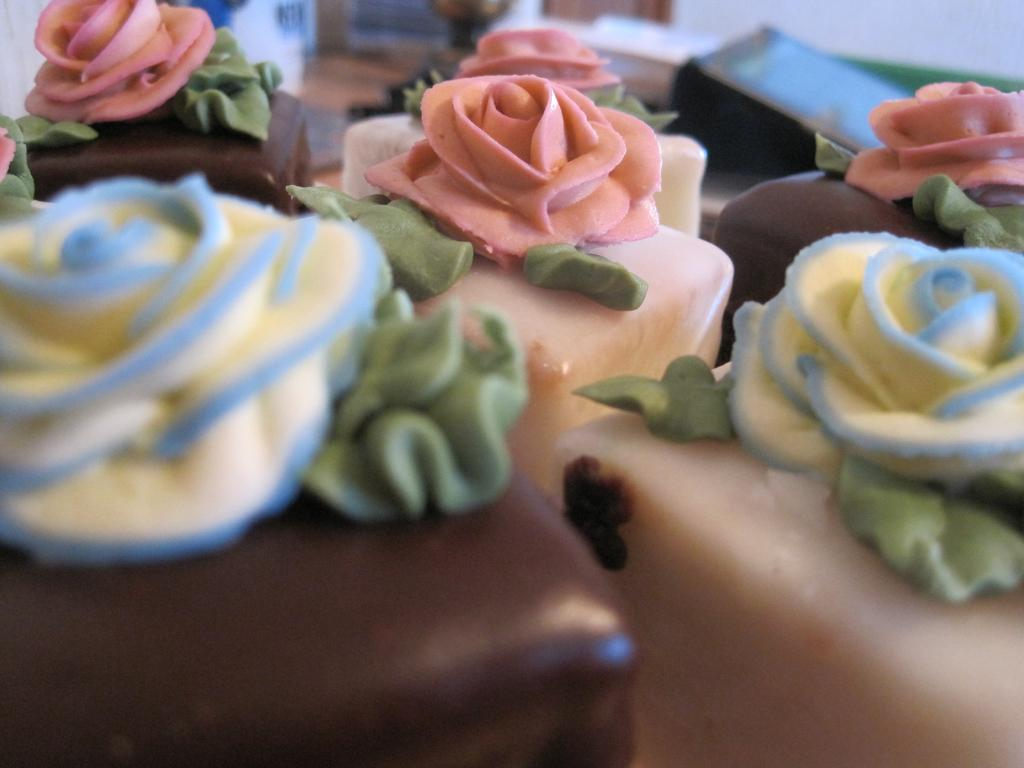What type of food is present in the image? The image contains cakes. Can you hear the cakes crying in the image? The image does not contain any audible elements, and therefore the cakes cannot be heard crying. 